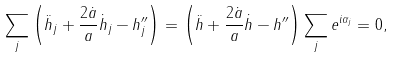<formula> <loc_0><loc_0><loc_500><loc_500>\sum _ { j } \left ( \ddot { h } _ { j } + \frac { 2 \dot { a } } { a } \dot { h } _ { j } - h _ { j } ^ { \prime \prime } \right ) = \left ( \ddot { h } + \frac { 2 \dot { a } } { a } \dot { h } - h ^ { \prime \prime } \right ) \sum _ { j } e ^ { i \alpha _ { j } } = 0 ,</formula> 